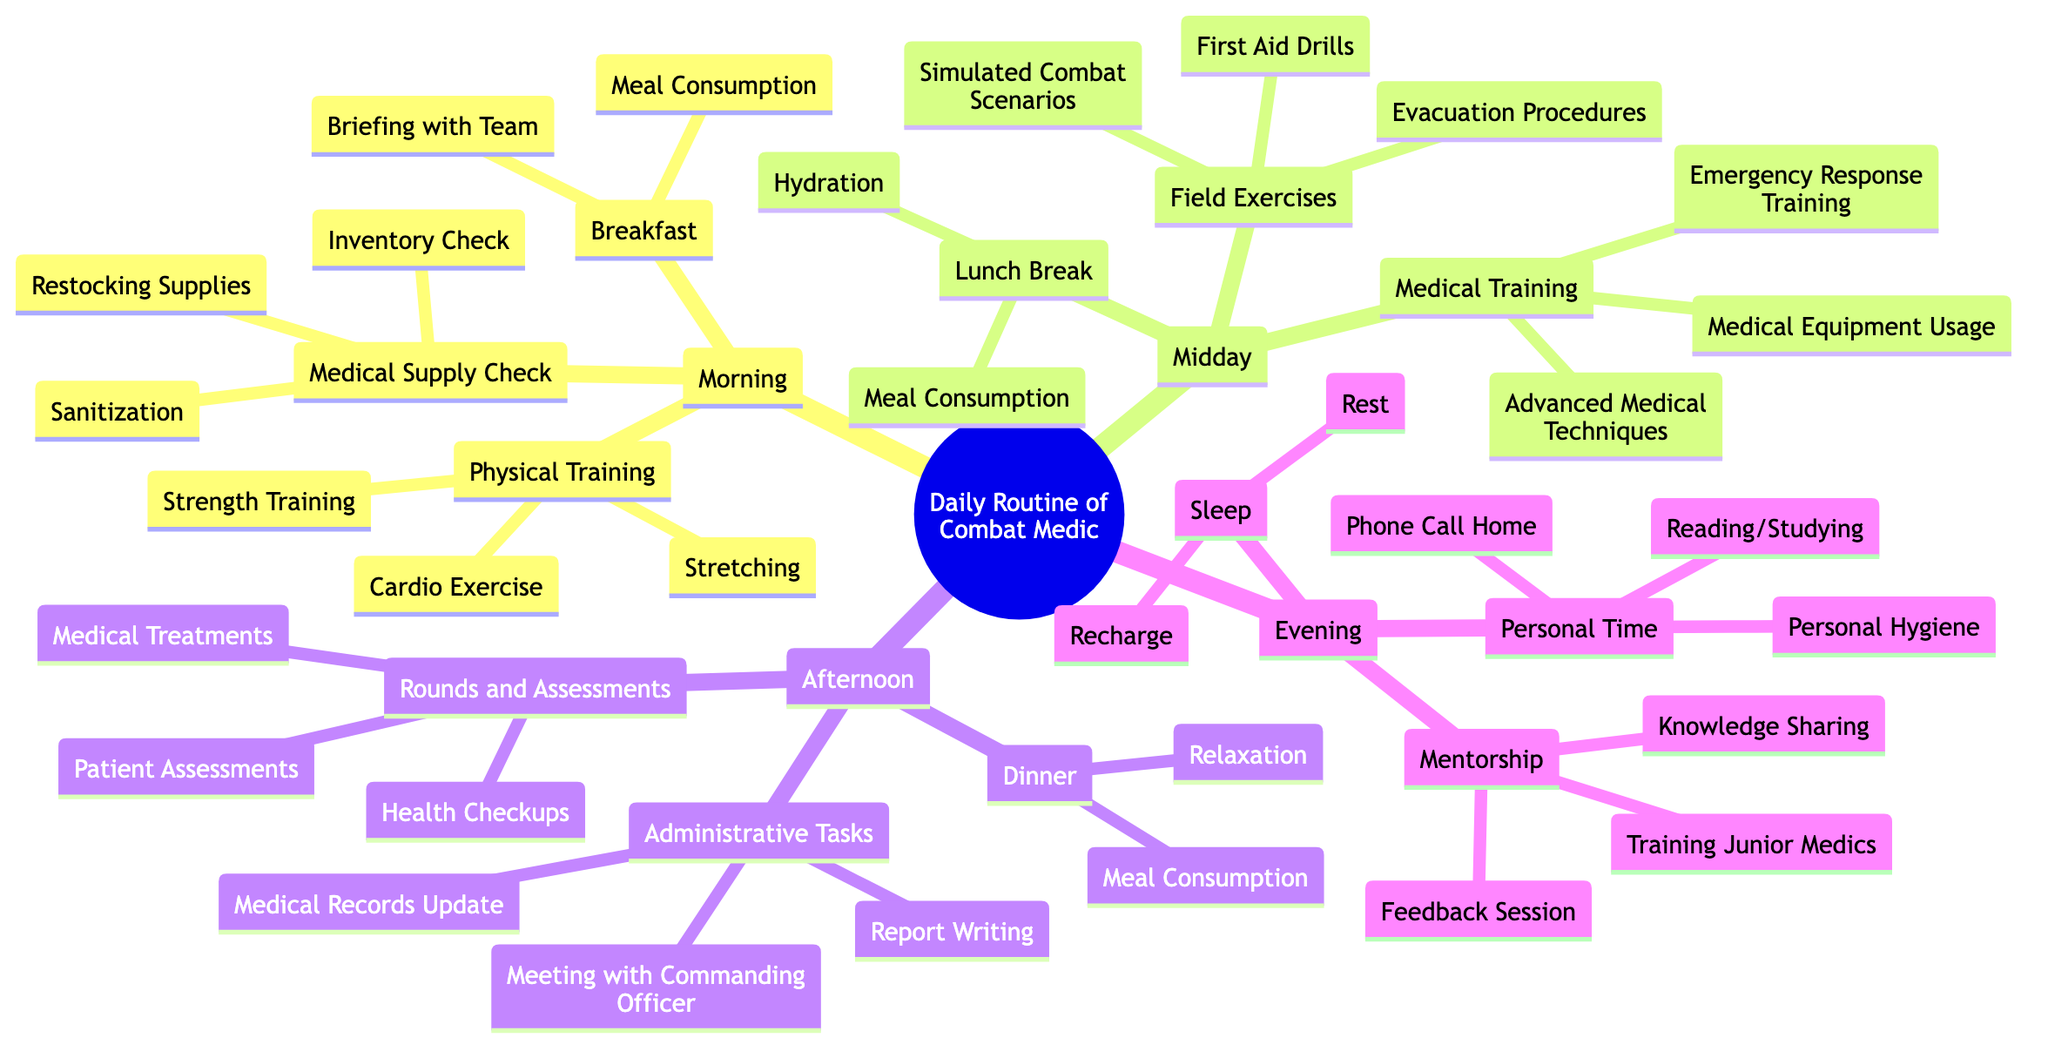What time does Physical Training occur? The diagram indicates that Physical Training is scheduled from 0600 to 0700. This is a straightforward read of the "Time" node under "Physical Training" in the Morning section.
Answer: 0600-0700 How many activities are listed under Medical Supply Check? Under the Medical Supply Check node, there are three activities enumerated: Inventory Check, Restocking Supplies, and Sanitization. This count can be derived by simply counting the listed activities under that heading.
Answer: 3 What are the main responsibilities during the Midday Medical Training? The Midday Medical Training section includes the following three activities: Advanced Medical Techniques, Medical Equipment Usage, and Emergency Response Training. This is identified by examining the activities listed under that specific node.
Answer: Advanced Medical Techniques, Medical Equipment Usage, Emergency Response Training Which activity occurs right after Lunch Break? Following the Lunch Break, as shown in the Midday section, the next activity listed is Medical Training. This is determined by observing the sequence of activities in that part of the diagram.
Answer: Medical Training What is the total duration of Personal Time? The diagram notes that Personal Time spans from 1900 to 2100, which is a total of 2 hours. To calculate duration, we subtract the starting time from the ending time.
Answer: 2 hours How many main sections are in the Daily Routine of a Combat Medic? The diagram is divided into four main sections: Morning, Midday, Afternoon, and Evening. This is identified by counting the primary nodes that categorize the daily routine.
Answer: 4 What activities are included in the Evening Mentorship? The activities listed under the Evening Mentorship node are Training Junior Medics, Knowledge Sharing, and Feedback Session. By looking at the sub-nodes under Mentorship, we can enumerate these activities.
Answer: Training Junior Medics, Knowledge Sharing, Feedback Session What does the Evening schedule conclude with? According to the diagram, the Evening schedule concludes with Sleep, which is the last activity listed under that section. This can be verified by checking the final node in the Evening category.
Answer: Sleep What is punctuated between Dinner and Mentorship in the schedule? The diagram does not list any activities between Dinner and Mentorship, meaning there is a direct transition from one to the other. This can be seen by looking at the time slots provided under these two nodes.
Answer: None 